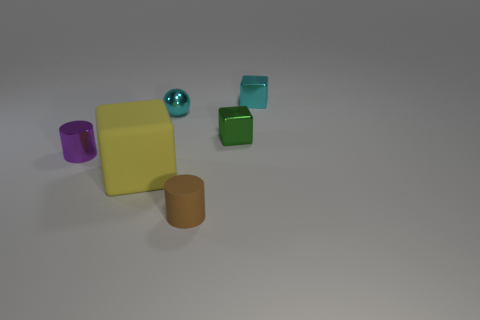Subtract all metal cubes. How many cubes are left? 1 Subtract all yellow blocks. How many blocks are left? 2 Add 3 big yellow objects. How many objects exist? 9 Subtract all balls. How many objects are left? 5 Subtract 1 blocks. How many blocks are left? 2 Subtract all cyan spheres. How many brown blocks are left? 0 Subtract all tiny blocks. Subtract all small green cylinders. How many objects are left? 4 Add 3 yellow rubber things. How many yellow rubber things are left? 4 Add 5 small cyan metal balls. How many small cyan metal balls exist? 6 Subtract 0 gray cubes. How many objects are left? 6 